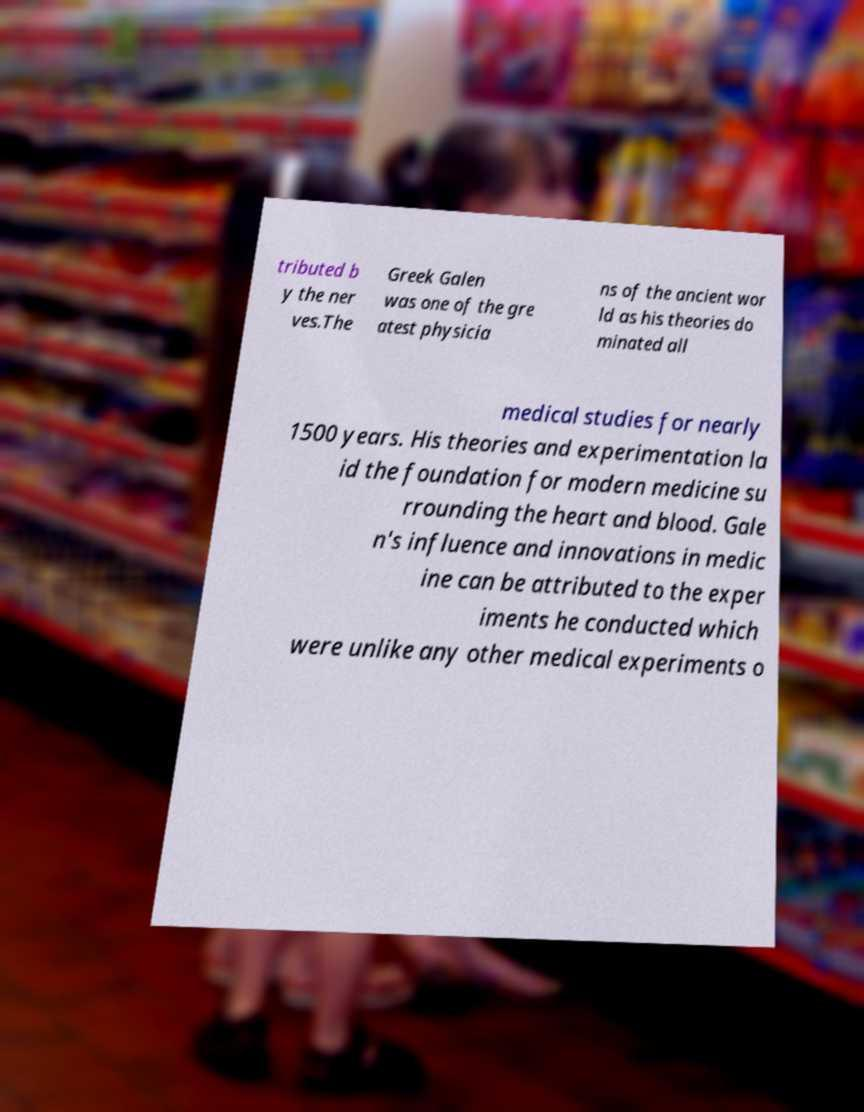Can you accurately transcribe the text from the provided image for me? tributed b y the ner ves.The Greek Galen was one of the gre atest physicia ns of the ancient wor ld as his theories do minated all medical studies for nearly 1500 years. His theories and experimentation la id the foundation for modern medicine su rrounding the heart and blood. Gale n's influence and innovations in medic ine can be attributed to the exper iments he conducted which were unlike any other medical experiments o 